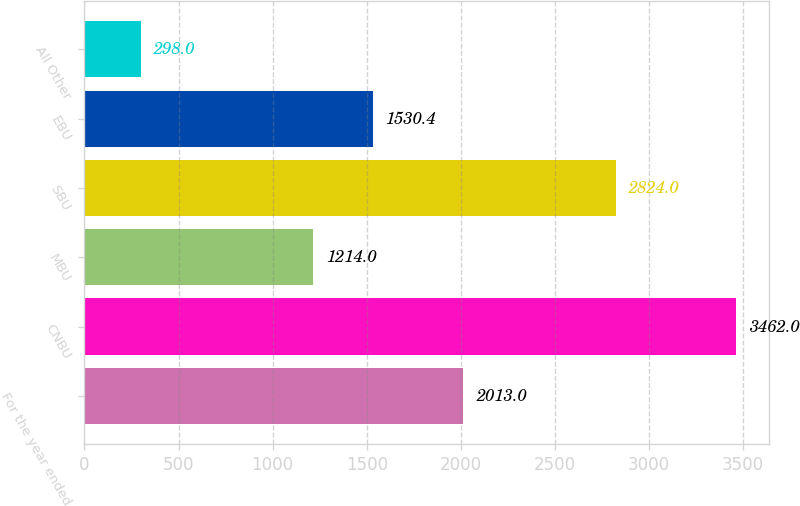Convert chart to OTSL. <chart><loc_0><loc_0><loc_500><loc_500><bar_chart><fcel>For the year ended<fcel>CNBU<fcel>MBU<fcel>SBU<fcel>EBU<fcel>All Other<nl><fcel>2013<fcel>3462<fcel>1214<fcel>2824<fcel>1530.4<fcel>298<nl></chart> 